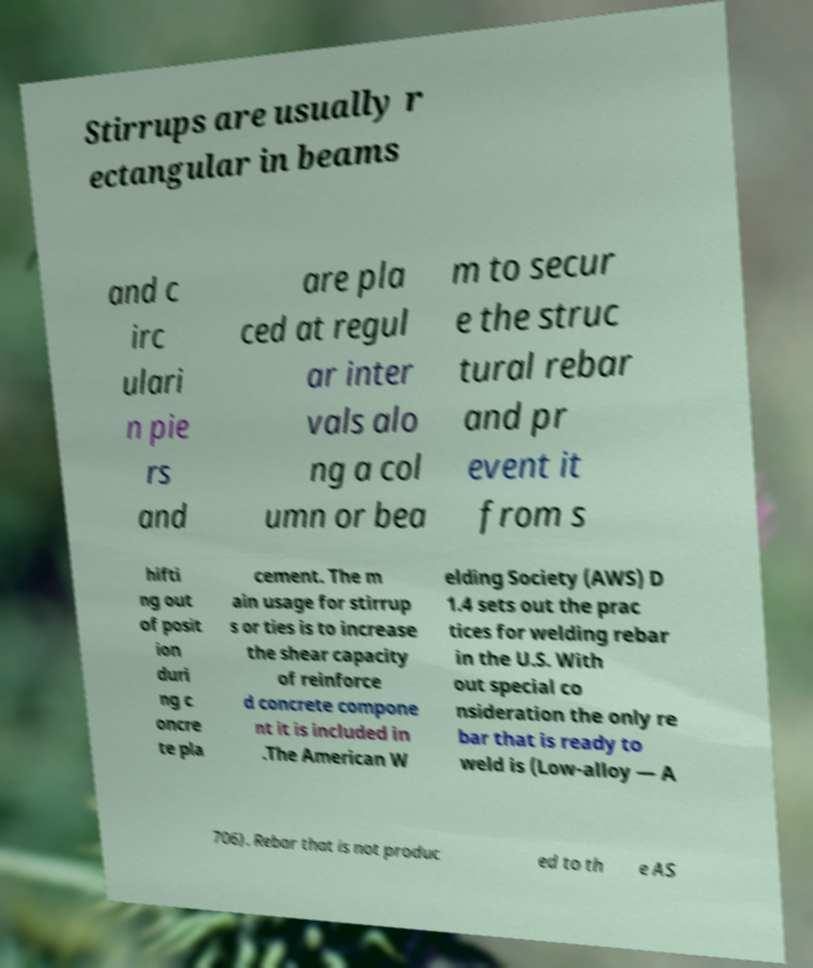Please read and relay the text visible in this image. What does it say? Stirrups are usually r ectangular in beams and c irc ulari n pie rs and are pla ced at regul ar inter vals alo ng a col umn or bea m to secur e the struc tural rebar and pr event it from s hifti ng out of posit ion duri ng c oncre te pla cement. The m ain usage for stirrup s or ties is to increase the shear capacity of reinforce d concrete compone nt it is included in .The American W elding Society (AWS) D 1.4 sets out the prac tices for welding rebar in the U.S. With out special co nsideration the only re bar that is ready to weld is (Low-alloy — A 706). Rebar that is not produc ed to th e AS 